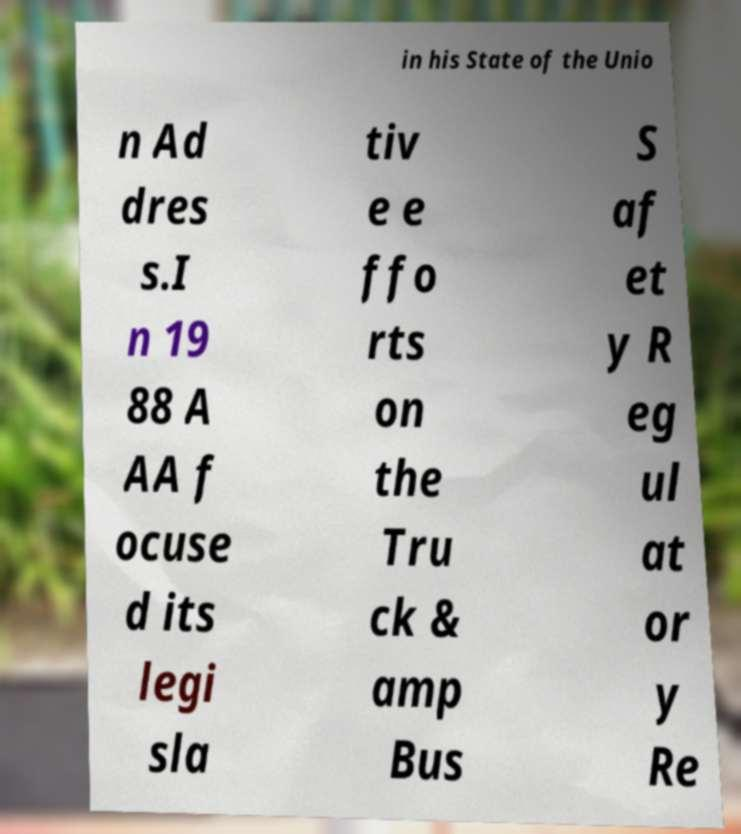Please read and relay the text visible in this image. What does it say? in his State of the Unio n Ad dres s.I n 19 88 A AA f ocuse d its legi sla tiv e e ffo rts on the Tru ck & amp Bus S af et y R eg ul at or y Re 